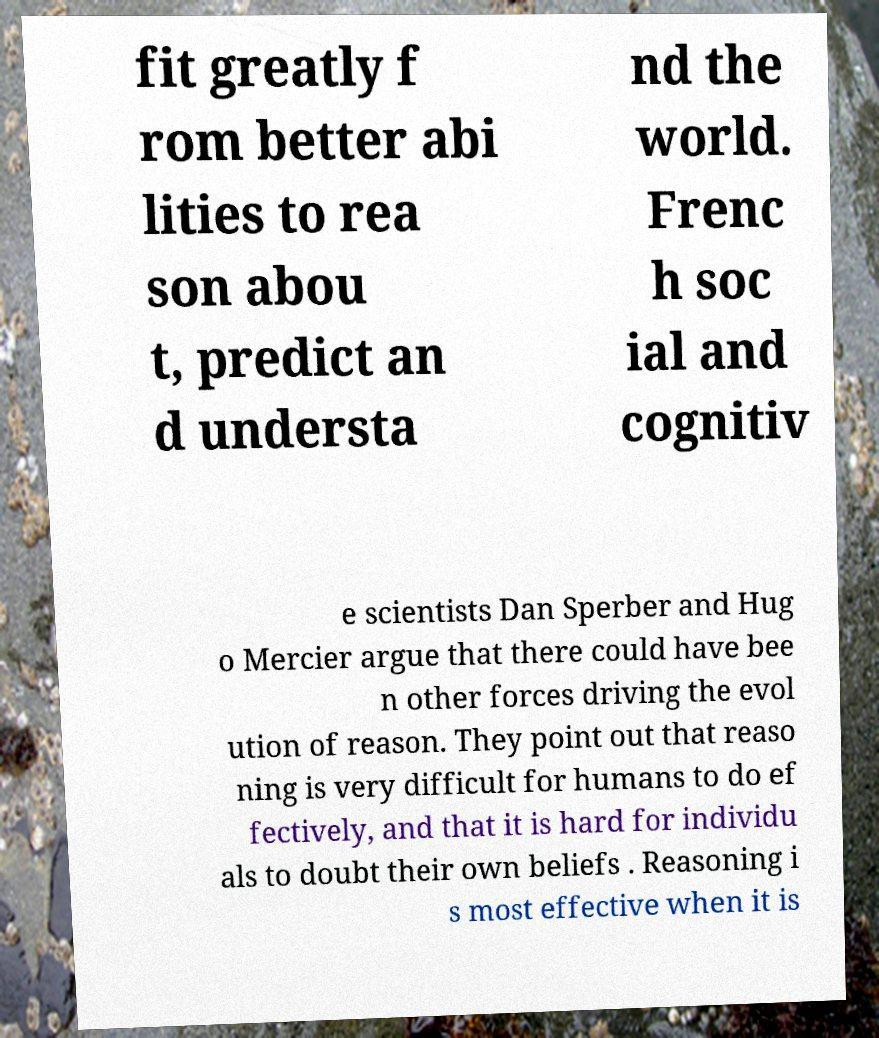Could you assist in decoding the text presented in this image and type it out clearly? fit greatly f rom better abi lities to rea son abou t, predict an d understa nd the world. Frenc h soc ial and cognitiv e scientists Dan Sperber and Hug o Mercier argue that there could have bee n other forces driving the evol ution of reason. They point out that reaso ning is very difficult for humans to do ef fectively, and that it is hard for individu als to doubt their own beliefs . Reasoning i s most effective when it is 